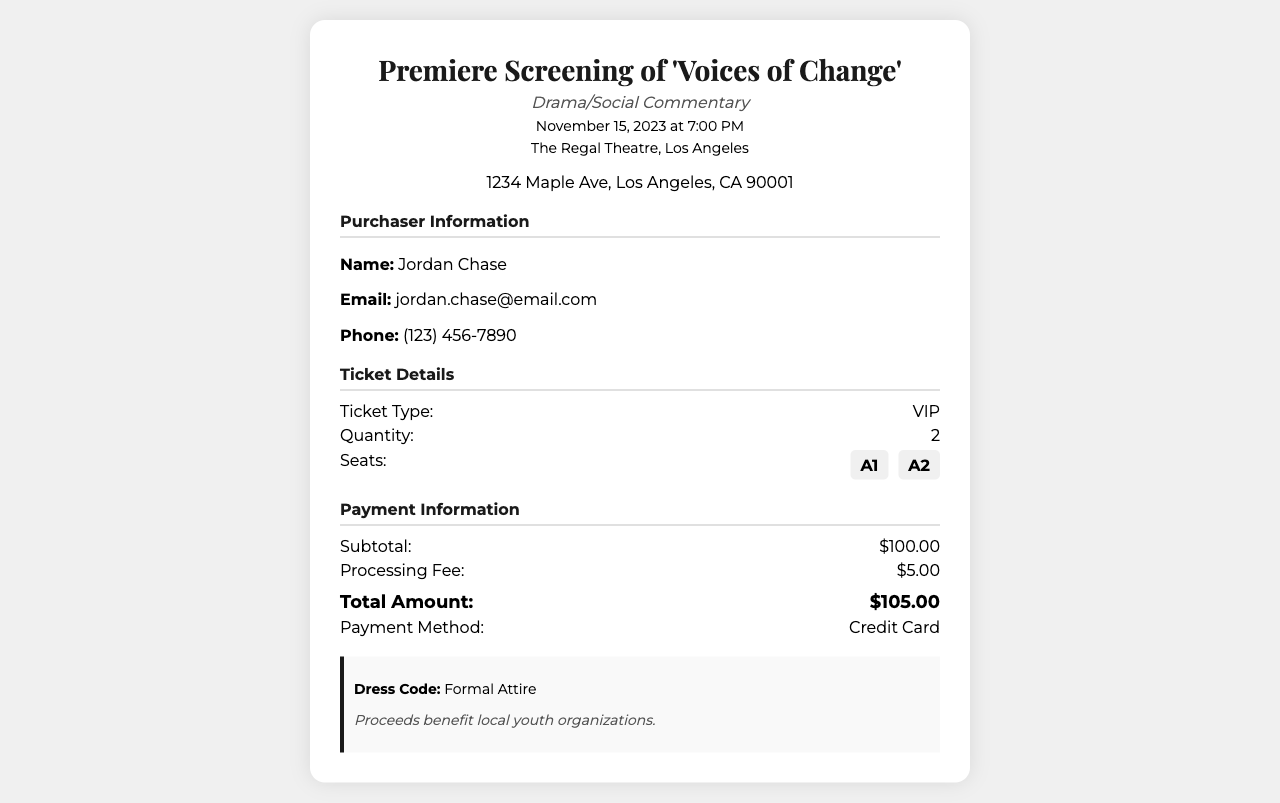What is the title of the film? The title of the film is presented at the top of the receipt.
Answer: Voices of Change What type of film is it? The type of film is categorized in the subtitle section.
Answer: Drama/Social Commentary What is the date of the screening? The date of the screening can be found in the date-time section.
Answer: November 15, 2023 How many VIP tickets were purchased? The quantity of tickets is indicated in the ticket details section.
Answer: 2 What are the seat numbers? The seat numbers are listed in the ticket details section under 'Seats'.
Answer: A1, A2 What was the subtotal amount? The subtotal is specified in the payment information part of the receipt.
Answer: $100.00 What is the total amount paid? The total amount is the final figure presented in the payment information section.
Answer: $105.00 What is the payment method used? The payment method is indicated in the payment information section of the document.
Answer: Credit Card What is the dress code for the premiere? The dress code is mentioned in the notes section of the receipt.
Answer: Formal Attire 